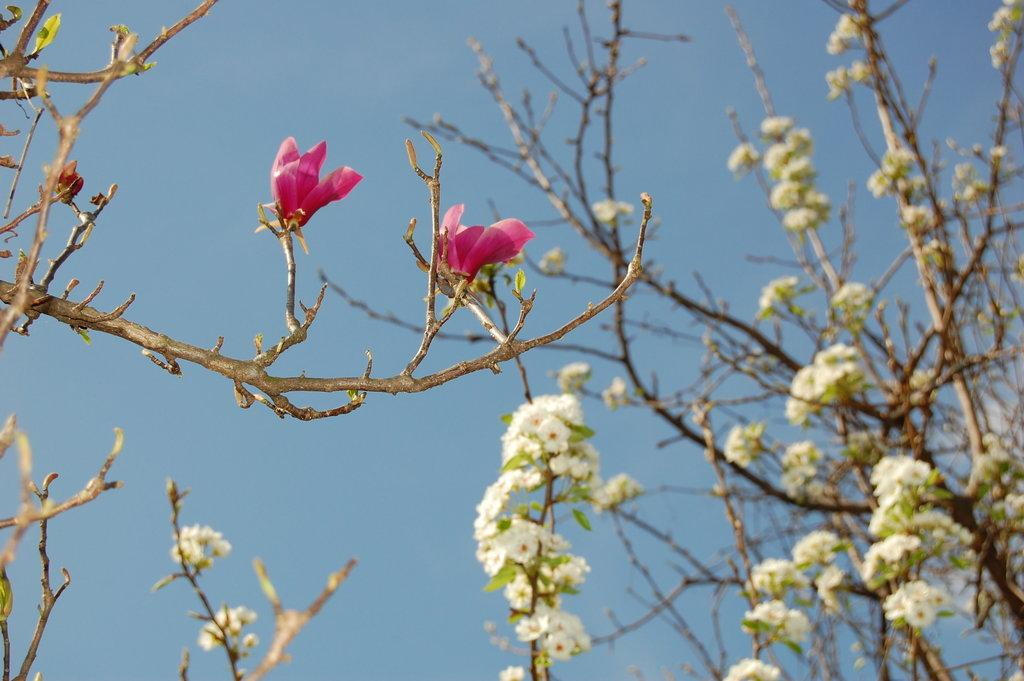What color are the flowers on the tree in the image? The flowers on the tree are pink. Can you describe the quality of the image? The image is slightly blurred. What can be seen in the background of the image? There is a blue sky visible in the background. What type of beam is holding up the tree in the image? There is no beam present in the image; the tree is standing on its own. Can you read the letter on the tree trunk in the image? There is no letter visible on the tree trunk in the image. 